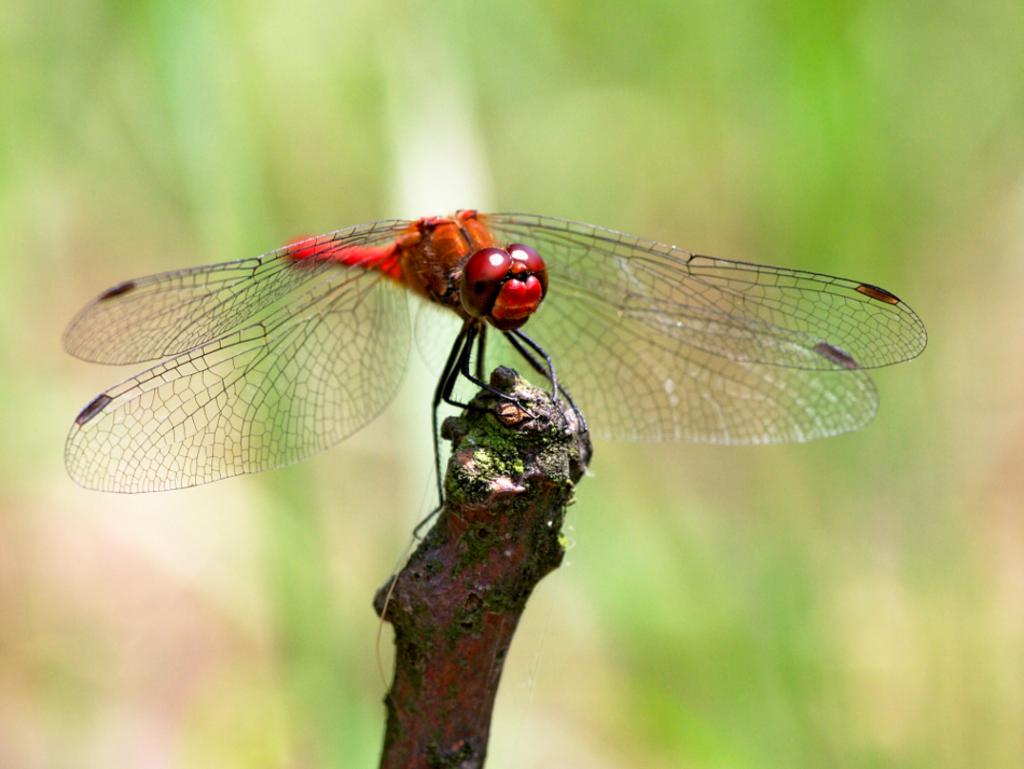What is the main subject of the image? The main subject of the image is a fly on a branch. Can you describe the background of the image? The background of the image is blurred. What type of pen is the fly holding in the image? There is no pen present in the image, as the main subject is a fly on a branch. 